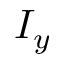Convert formula to latex. <formula><loc_0><loc_0><loc_500><loc_500>I _ { y }</formula> 